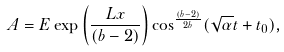Convert formula to latex. <formula><loc_0><loc_0><loc_500><loc_500>A = E \exp { \left ( \frac { L x } { ( b - 2 ) } \right ) } \cos ^ { \frac { ( b - 2 ) } { 2 b } } ( \sqrt { \alpha } t + t _ { 0 } ) ,</formula> 